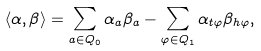Convert formula to latex. <formula><loc_0><loc_0><loc_500><loc_500>\langle \alpha , \beta \rangle = \sum _ { a \in Q _ { 0 } } \alpha _ { a } \beta _ { a } - \sum _ { \varphi \in Q _ { 1 } } \alpha _ { t \varphi } \beta _ { h \varphi } ,</formula> 